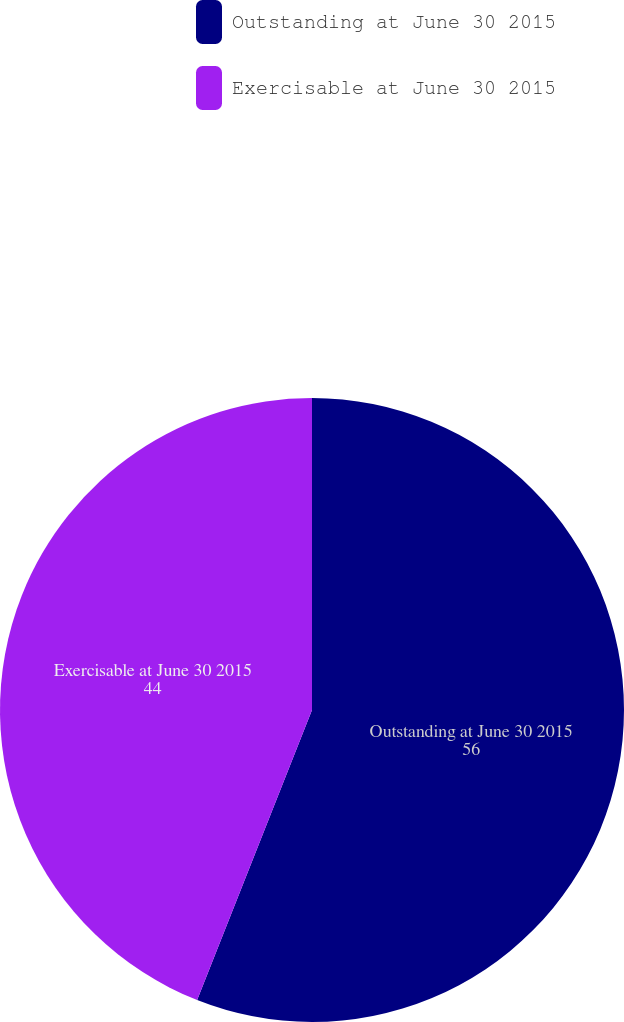Convert chart to OTSL. <chart><loc_0><loc_0><loc_500><loc_500><pie_chart><fcel>Outstanding at June 30 2015<fcel>Exercisable at June 30 2015<nl><fcel>56.0%<fcel>44.0%<nl></chart> 